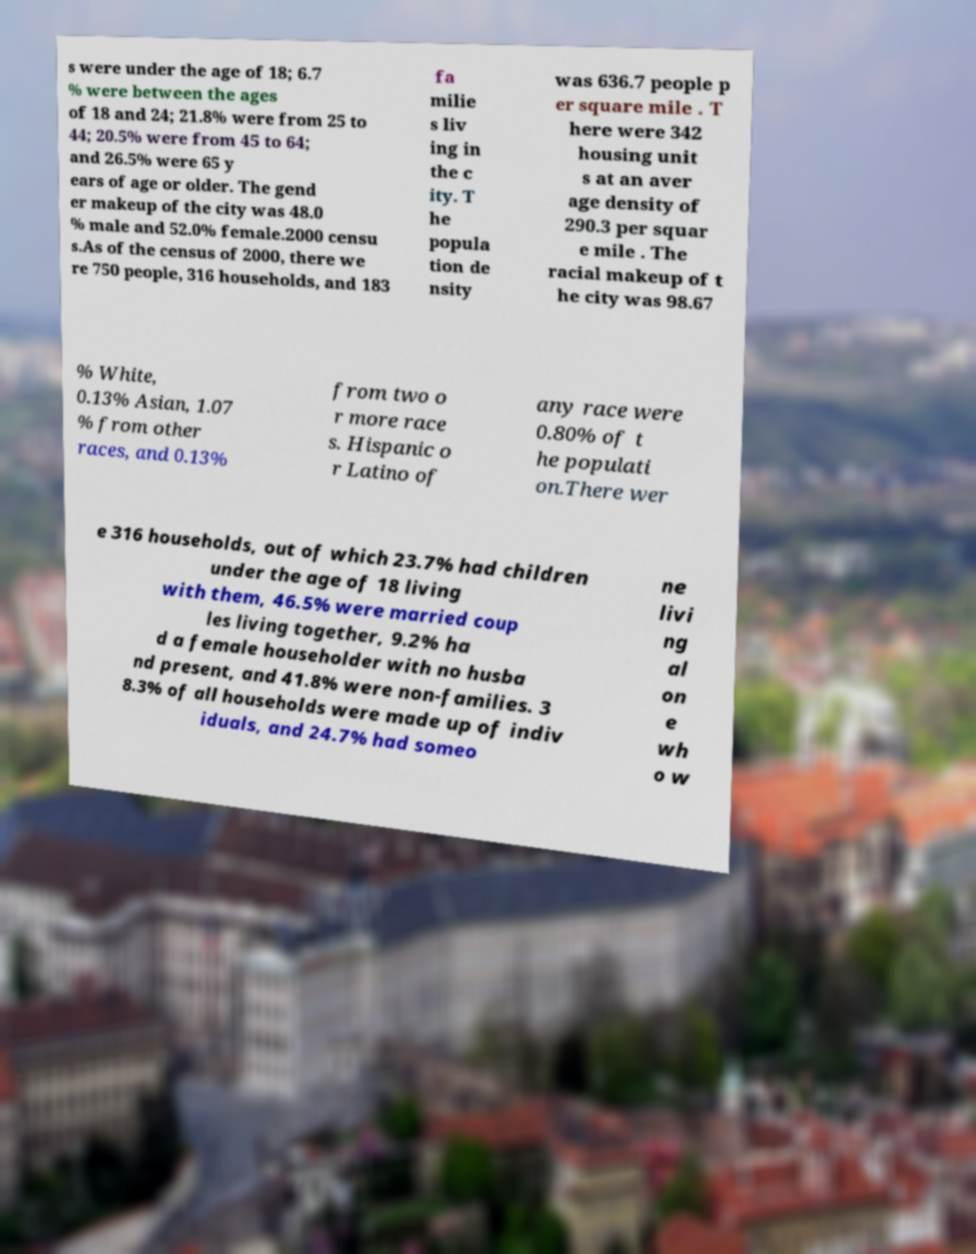I need the written content from this picture converted into text. Can you do that? s were under the age of 18; 6.7 % were between the ages of 18 and 24; 21.8% were from 25 to 44; 20.5% were from 45 to 64; and 26.5% were 65 y ears of age or older. The gend er makeup of the city was 48.0 % male and 52.0% female.2000 censu s.As of the census of 2000, there we re 750 people, 316 households, and 183 fa milie s liv ing in the c ity. T he popula tion de nsity was 636.7 people p er square mile . T here were 342 housing unit s at an aver age density of 290.3 per squar e mile . The racial makeup of t he city was 98.67 % White, 0.13% Asian, 1.07 % from other races, and 0.13% from two o r more race s. Hispanic o r Latino of any race were 0.80% of t he populati on.There wer e 316 households, out of which 23.7% had children under the age of 18 living with them, 46.5% were married coup les living together, 9.2% ha d a female householder with no husba nd present, and 41.8% were non-families. 3 8.3% of all households were made up of indiv iduals, and 24.7% had someo ne livi ng al on e wh o w 